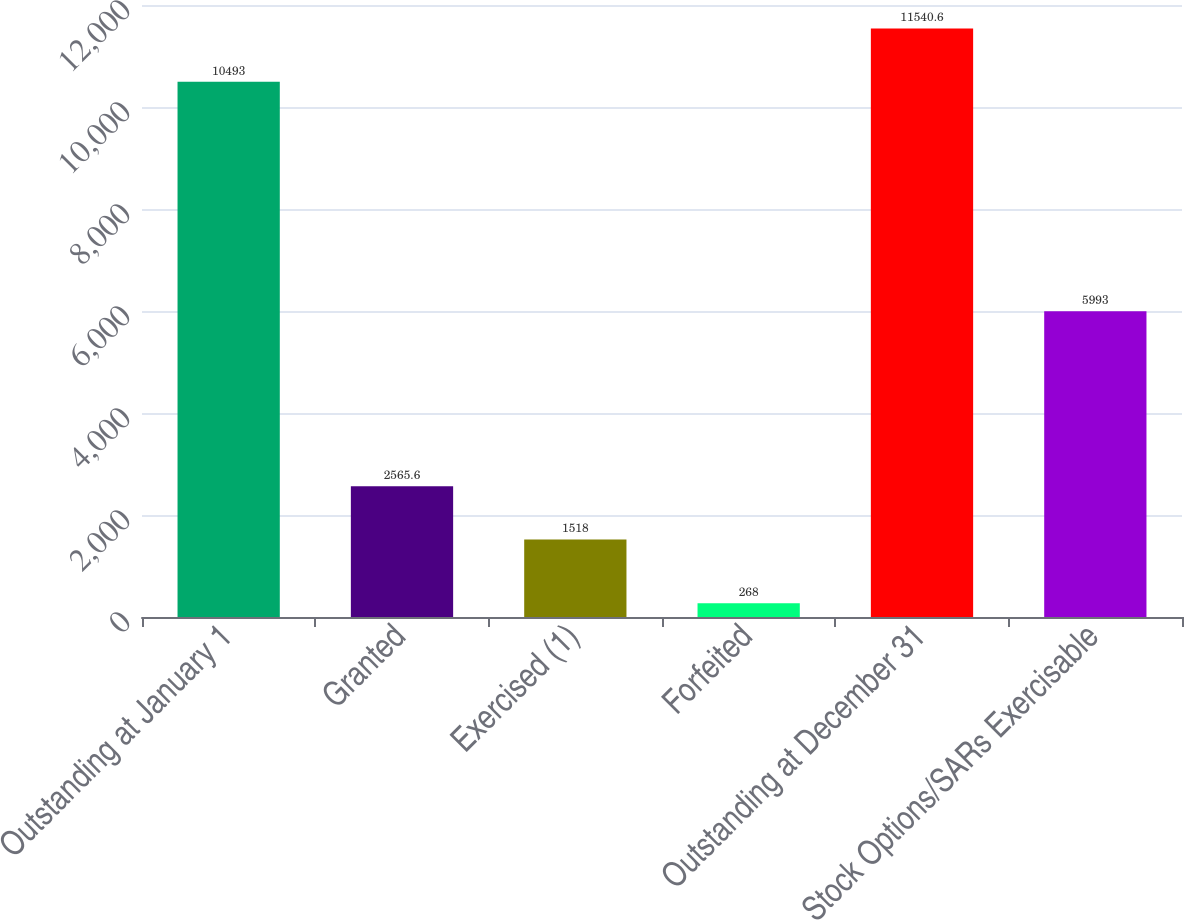<chart> <loc_0><loc_0><loc_500><loc_500><bar_chart><fcel>Outstanding at January 1<fcel>Granted<fcel>Exercised (1)<fcel>Forfeited<fcel>Outstanding at December 31<fcel>Stock Options/SARs Exercisable<nl><fcel>10493<fcel>2565.6<fcel>1518<fcel>268<fcel>11540.6<fcel>5993<nl></chart> 